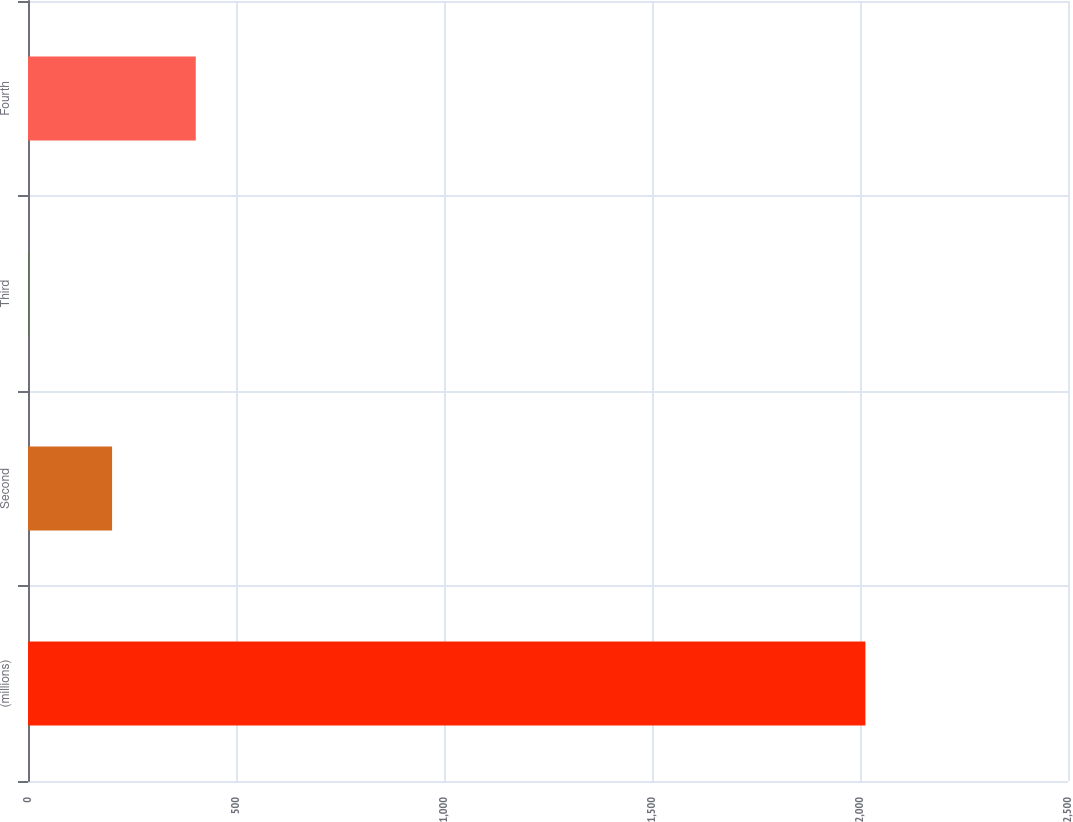<chart> <loc_0><loc_0><loc_500><loc_500><bar_chart><fcel>(millions)<fcel>Second<fcel>Third<fcel>Fourth<nl><fcel>2013<fcel>202.11<fcel>0.9<fcel>403.32<nl></chart> 